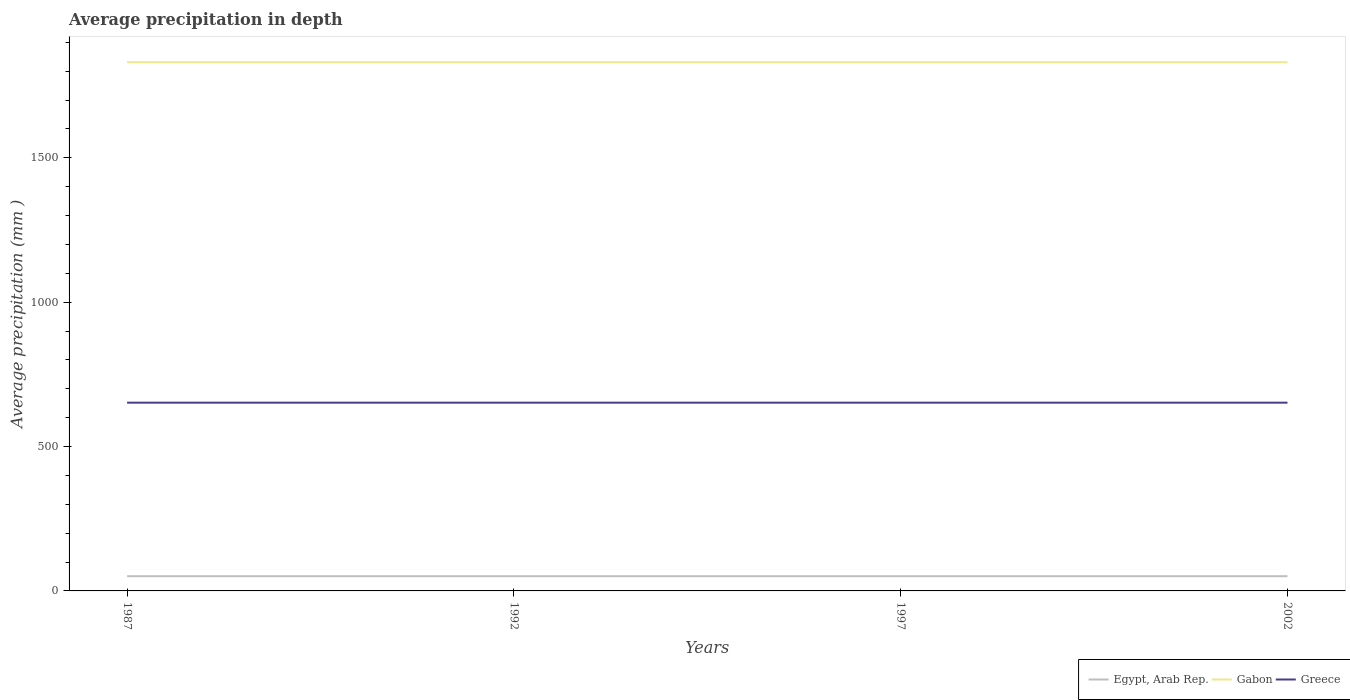How many different coloured lines are there?
Provide a short and direct response. 3. Across all years, what is the maximum average precipitation in Gabon?
Keep it short and to the point. 1831. What is the difference between the highest and the lowest average precipitation in Gabon?
Keep it short and to the point. 0. How many lines are there?
Provide a succinct answer. 3. How many years are there in the graph?
Ensure brevity in your answer.  4. Are the values on the major ticks of Y-axis written in scientific E-notation?
Keep it short and to the point. No. Where does the legend appear in the graph?
Make the answer very short. Bottom right. What is the title of the graph?
Offer a terse response. Average precipitation in depth. What is the label or title of the X-axis?
Keep it short and to the point. Years. What is the label or title of the Y-axis?
Offer a terse response. Average precipitation (mm ). What is the Average precipitation (mm ) in Gabon in 1987?
Provide a short and direct response. 1831. What is the Average precipitation (mm ) of Greece in 1987?
Ensure brevity in your answer.  652. What is the Average precipitation (mm ) in Egypt, Arab Rep. in 1992?
Your answer should be compact. 51. What is the Average precipitation (mm ) in Gabon in 1992?
Your answer should be very brief. 1831. What is the Average precipitation (mm ) in Greece in 1992?
Offer a terse response. 652. What is the Average precipitation (mm ) in Egypt, Arab Rep. in 1997?
Make the answer very short. 51. What is the Average precipitation (mm ) in Gabon in 1997?
Your response must be concise. 1831. What is the Average precipitation (mm ) in Greece in 1997?
Ensure brevity in your answer.  652. What is the Average precipitation (mm ) in Gabon in 2002?
Your response must be concise. 1831. What is the Average precipitation (mm ) of Greece in 2002?
Ensure brevity in your answer.  652. Across all years, what is the maximum Average precipitation (mm ) of Gabon?
Offer a terse response. 1831. Across all years, what is the maximum Average precipitation (mm ) in Greece?
Your response must be concise. 652. Across all years, what is the minimum Average precipitation (mm ) in Egypt, Arab Rep.?
Give a very brief answer. 51. Across all years, what is the minimum Average precipitation (mm ) of Gabon?
Ensure brevity in your answer.  1831. Across all years, what is the minimum Average precipitation (mm ) in Greece?
Offer a terse response. 652. What is the total Average precipitation (mm ) of Egypt, Arab Rep. in the graph?
Offer a very short reply. 204. What is the total Average precipitation (mm ) in Gabon in the graph?
Your answer should be compact. 7324. What is the total Average precipitation (mm ) of Greece in the graph?
Your answer should be compact. 2608. What is the difference between the Average precipitation (mm ) in Gabon in 1987 and that in 1992?
Make the answer very short. 0. What is the difference between the Average precipitation (mm ) of Egypt, Arab Rep. in 1987 and that in 1997?
Make the answer very short. 0. What is the difference between the Average precipitation (mm ) in Greece in 1987 and that in 1997?
Your response must be concise. 0. What is the difference between the Average precipitation (mm ) of Egypt, Arab Rep. in 1987 and that in 2002?
Your answer should be very brief. 0. What is the difference between the Average precipitation (mm ) of Gabon in 1987 and that in 2002?
Offer a terse response. 0. What is the difference between the Average precipitation (mm ) of Greece in 1987 and that in 2002?
Make the answer very short. 0. What is the difference between the Average precipitation (mm ) in Egypt, Arab Rep. in 1992 and that in 2002?
Offer a terse response. 0. What is the difference between the Average precipitation (mm ) of Gabon in 1992 and that in 2002?
Ensure brevity in your answer.  0. What is the difference between the Average precipitation (mm ) in Greece in 1992 and that in 2002?
Your answer should be compact. 0. What is the difference between the Average precipitation (mm ) of Gabon in 1997 and that in 2002?
Offer a very short reply. 0. What is the difference between the Average precipitation (mm ) in Greece in 1997 and that in 2002?
Ensure brevity in your answer.  0. What is the difference between the Average precipitation (mm ) in Egypt, Arab Rep. in 1987 and the Average precipitation (mm ) in Gabon in 1992?
Keep it short and to the point. -1780. What is the difference between the Average precipitation (mm ) of Egypt, Arab Rep. in 1987 and the Average precipitation (mm ) of Greece in 1992?
Your answer should be compact. -601. What is the difference between the Average precipitation (mm ) of Gabon in 1987 and the Average precipitation (mm ) of Greece in 1992?
Provide a short and direct response. 1179. What is the difference between the Average precipitation (mm ) of Egypt, Arab Rep. in 1987 and the Average precipitation (mm ) of Gabon in 1997?
Offer a terse response. -1780. What is the difference between the Average precipitation (mm ) of Egypt, Arab Rep. in 1987 and the Average precipitation (mm ) of Greece in 1997?
Provide a short and direct response. -601. What is the difference between the Average precipitation (mm ) in Gabon in 1987 and the Average precipitation (mm ) in Greece in 1997?
Offer a very short reply. 1179. What is the difference between the Average precipitation (mm ) of Egypt, Arab Rep. in 1987 and the Average precipitation (mm ) of Gabon in 2002?
Keep it short and to the point. -1780. What is the difference between the Average precipitation (mm ) in Egypt, Arab Rep. in 1987 and the Average precipitation (mm ) in Greece in 2002?
Your answer should be very brief. -601. What is the difference between the Average precipitation (mm ) in Gabon in 1987 and the Average precipitation (mm ) in Greece in 2002?
Provide a short and direct response. 1179. What is the difference between the Average precipitation (mm ) of Egypt, Arab Rep. in 1992 and the Average precipitation (mm ) of Gabon in 1997?
Provide a succinct answer. -1780. What is the difference between the Average precipitation (mm ) in Egypt, Arab Rep. in 1992 and the Average precipitation (mm ) in Greece in 1997?
Your answer should be very brief. -601. What is the difference between the Average precipitation (mm ) of Gabon in 1992 and the Average precipitation (mm ) of Greece in 1997?
Keep it short and to the point. 1179. What is the difference between the Average precipitation (mm ) in Egypt, Arab Rep. in 1992 and the Average precipitation (mm ) in Gabon in 2002?
Offer a very short reply. -1780. What is the difference between the Average precipitation (mm ) of Egypt, Arab Rep. in 1992 and the Average precipitation (mm ) of Greece in 2002?
Give a very brief answer. -601. What is the difference between the Average precipitation (mm ) in Gabon in 1992 and the Average precipitation (mm ) in Greece in 2002?
Give a very brief answer. 1179. What is the difference between the Average precipitation (mm ) in Egypt, Arab Rep. in 1997 and the Average precipitation (mm ) in Gabon in 2002?
Your answer should be compact. -1780. What is the difference between the Average precipitation (mm ) of Egypt, Arab Rep. in 1997 and the Average precipitation (mm ) of Greece in 2002?
Offer a very short reply. -601. What is the difference between the Average precipitation (mm ) of Gabon in 1997 and the Average precipitation (mm ) of Greece in 2002?
Your answer should be very brief. 1179. What is the average Average precipitation (mm ) of Egypt, Arab Rep. per year?
Offer a terse response. 51. What is the average Average precipitation (mm ) of Gabon per year?
Give a very brief answer. 1831. What is the average Average precipitation (mm ) in Greece per year?
Make the answer very short. 652. In the year 1987, what is the difference between the Average precipitation (mm ) of Egypt, Arab Rep. and Average precipitation (mm ) of Gabon?
Your answer should be very brief. -1780. In the year 1987, what is the difference between the Average precipitation (mm ) of Egypt, Arab Rep. and Average precipitation (mm ) of Greece?
Offer a very short reply. -601. In the year 1987, what is the difference between the Average precipitation (mm ) of Gabon and Average precipitation (mm ) of Greece?
Offer a terse response. 1179. In the year 1992, what is the difference between the Average precipitation (mm ) in Egypt, Arab Rep. and Average precipitation (mm ) in Gabon?
Ensure brevity in your answer.  -1780. In the year 1992, what is the difference between the Average precipitation (mm ) of Egypt, Arab Rep. and Average precipitation (mm ) of Greece?
Provide a short and direct response. -601. In the year 1992, what is the difference between the Average precipitation (mm ) of Gabon and Average precipitation (mm ) of Greece?
Ensure brevity in your answer.  1179. In the year 1997, what is the difference between the Average precipitation (mm ) in Egypt, Arab Rep. and Average precipitation (mm ) in Gabon?
Offer a very short reply. -1780. In the year 1997, what is the difference between the Average precipitation (mm ) of Egypt, Arab Rep. and Average precipitation (mm ) of Greece?
Keep it short and to the point. -601. In the year 1997, what is the difference between the Average precipitation (mm ) in Gabon and Average precipitation (mm ) in Greece?
Ensure brevity in your answer.  1179. In the year 2002, what is the difference between the Average precipitation (mm ) of Egypt, Arab Rep. and Average precipitation (mm ) of Gabon?
Your response must be concise. -1780. In the year 2002, what is the difference between the Average precipitation (mm ) of Egypt, Arab Rep. and Average precipitation (mm ) of Greece?
Ensure brevity in your answer.  -601. In the year 2002, what is the difference between the Average precipitation (mm ) in Gabon and Average precipitation (mm ) in Greece?
Make the answer very short. 1179. What is the ratio of the Average precipitation (mm ) of Gabon in 1987 to that in 1992?
Provide a short and direct response. 1. What is the ratio of the Average precipitation (mm ) in Greece in 1987 to that in 1992?
Provide a succinct answer. 1. What is the ratio of the Average precipitation (mm ) in Egypt, Arab Rep. in 1987 to that in 1997?
Your answer should be compact. 1. What is the ratio of the Average precipitation (mm ) of Gabon in 1987 to that in 1997?
Your answer should be very brief. 1. What is the ratio of the Average precipitation (mm ) in Greece in 1987 to that in 1997?
Offer a terse response. 1. What is the ratio of the Average precipitation (mm ) in Egypt, Arab Rep. in 1987 to that in 2002?
Give a very brief answer. 1. What is the ratio of the Average precipitation (mm ) in Gabon in 1987 to that in 2002?
Ensure brevity in your answer.  1. What is the ratio of the Average precipitation (mm ) of Egypt, Arab Rep. in 1992 to that in 1997?
Provide a short and direct response. 1. What is the ratio of the Average precipitation (mm ) in Gabon in 1992 to that in 1997?
Ensure brevity in your answer.  1. What is the ratio of the Average precipitation (mm ) of Greece in 1992 to that in 1997?
Offer a terse response. 1. What is the ratio of the Average precipitation (mm ) of Egypt, Arab Rep. in 1992 to that in 2002?
Your answer should be very brief. 1. What is the ratio of the Average precipitation (mm ) of Greece in 1997 to that in 2002?
Offer a terse response. 1. What is the difference between the highest and the second highest Average precipitation (mm ) in Egypt, Arab Rep.?
Offer a very short reply. 0. What is the difference between the highest and the lowest Average precipitation (mm ) in Greece?
Provide a short and direct response. 0. 